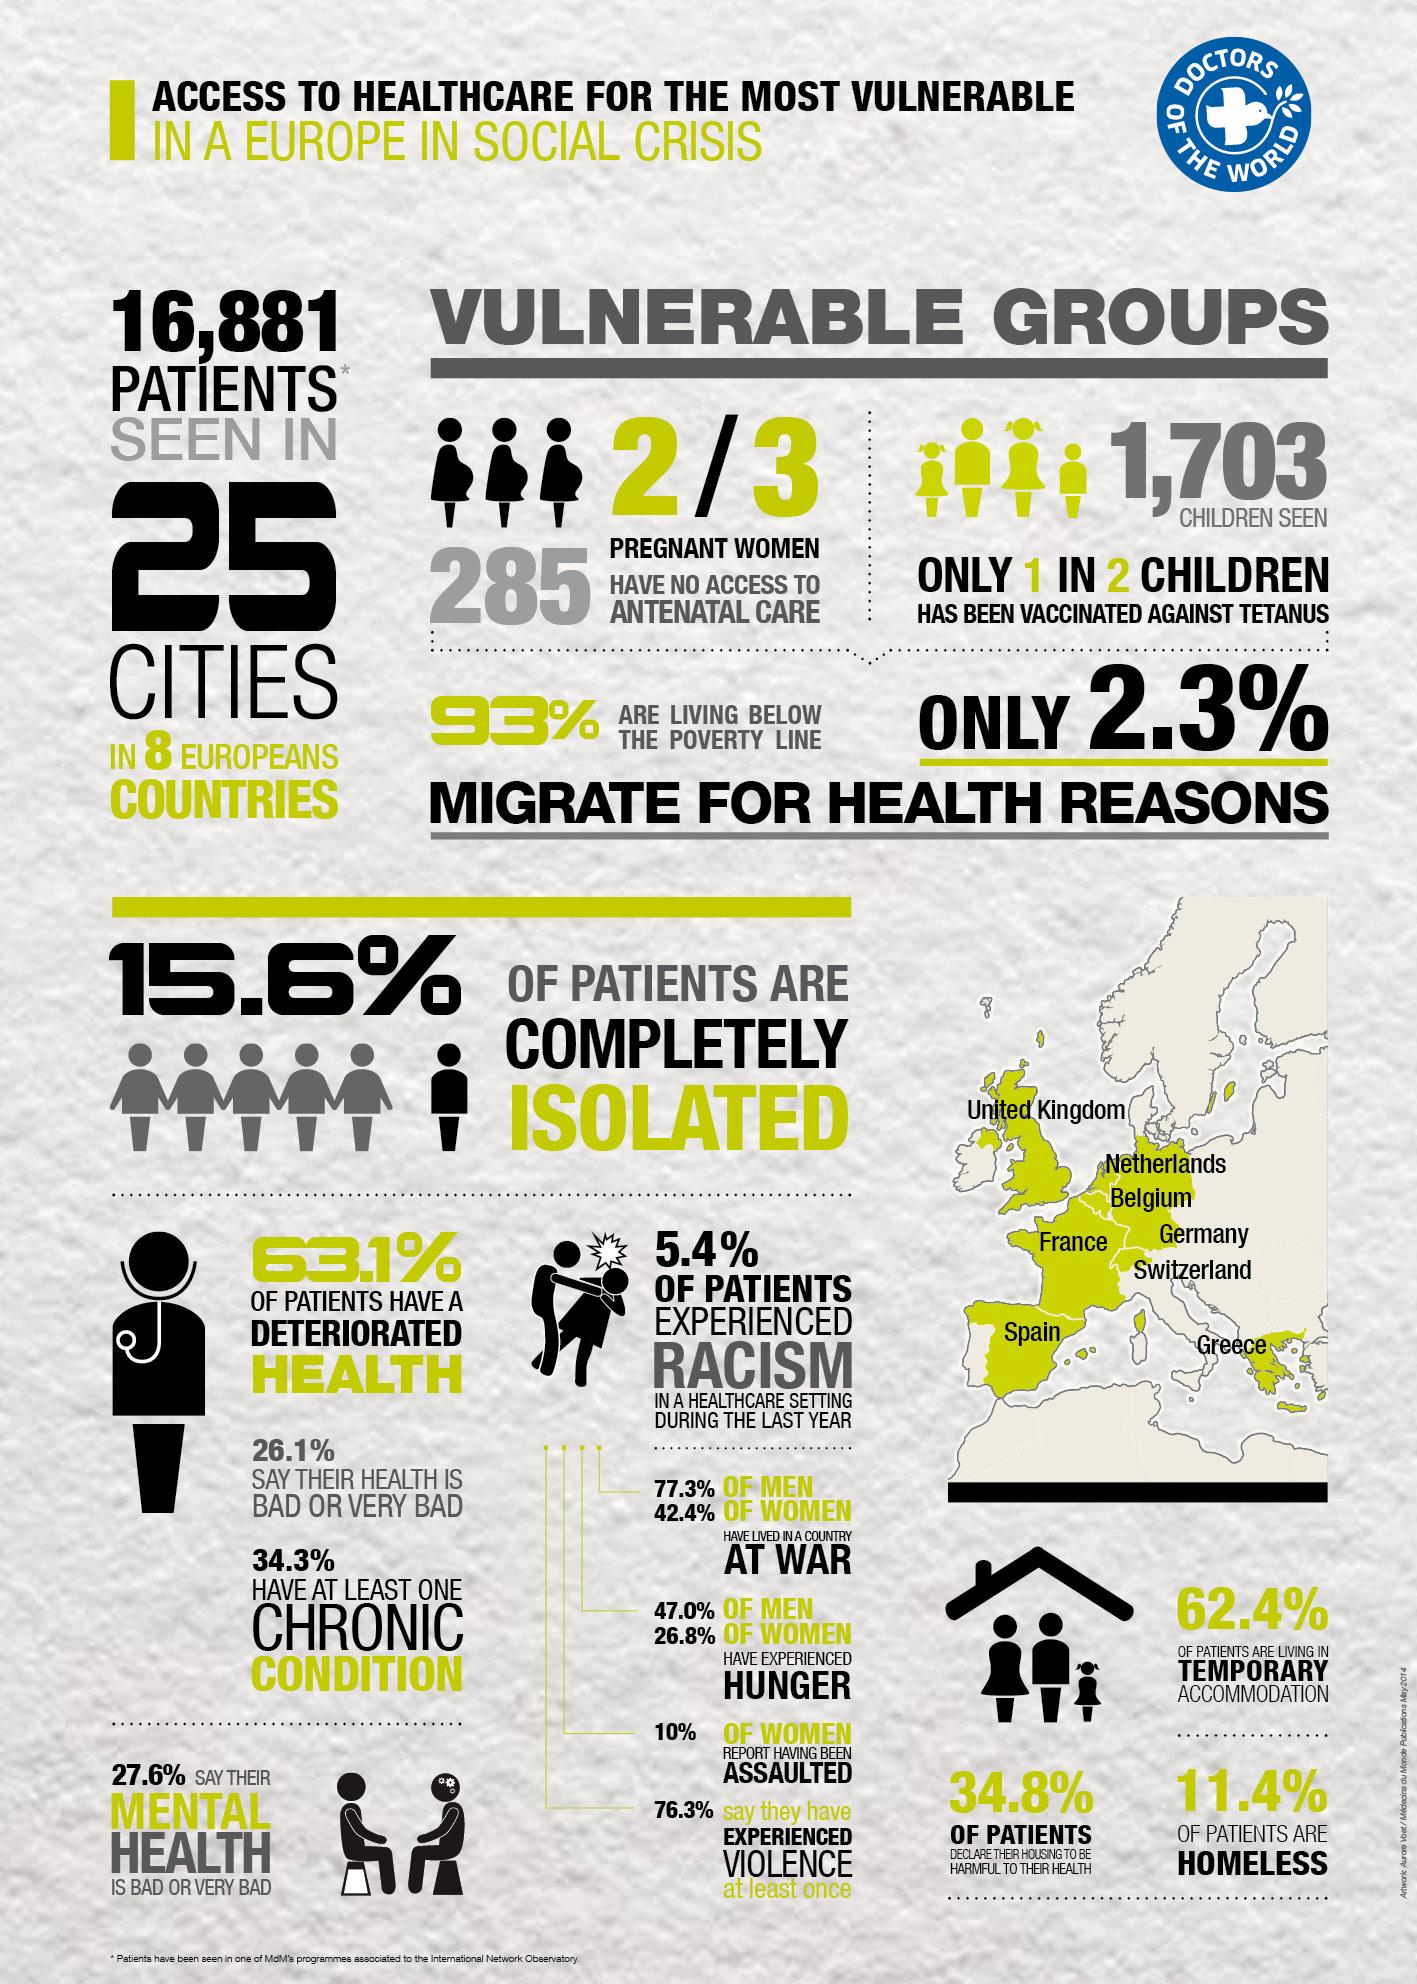List a handful of essential elements in this visual. A significant percentage of men, approximately 77.3%, have lived in a country that has been at war. A recent survey in Europe has revealed that 47.0% of men have experienced hunger. According to the data, 34.3% of patients have at least one chronic condition. In Europe, an estimated 285 pregnant women lack access to antenatal care. According to recent data, only 7% of the population in Europe is living above the poverty line. This is a significant concern as it highlights the widespread issue of poverty in the region. 